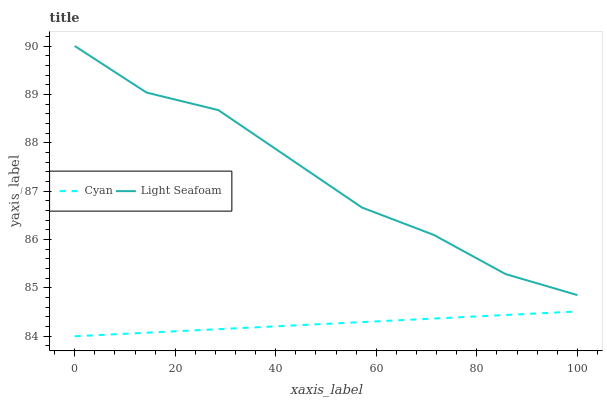Does Light Seafoam have the minimum area under the curve?
Answer yes or no. No. Is Light Seafoam the smoothest?
Answer yes or no. No. Does Light Seafoam have the lowest value?
Answer yes or no. No. Is Cyan less than Light Seafoam?
Answer yes or no. Yes. Is Light Seafoam greater than Cyan?
Answer yes or no. Yes. Does Cyan intersect Light Seafoam?
Answer yes or no. No. 